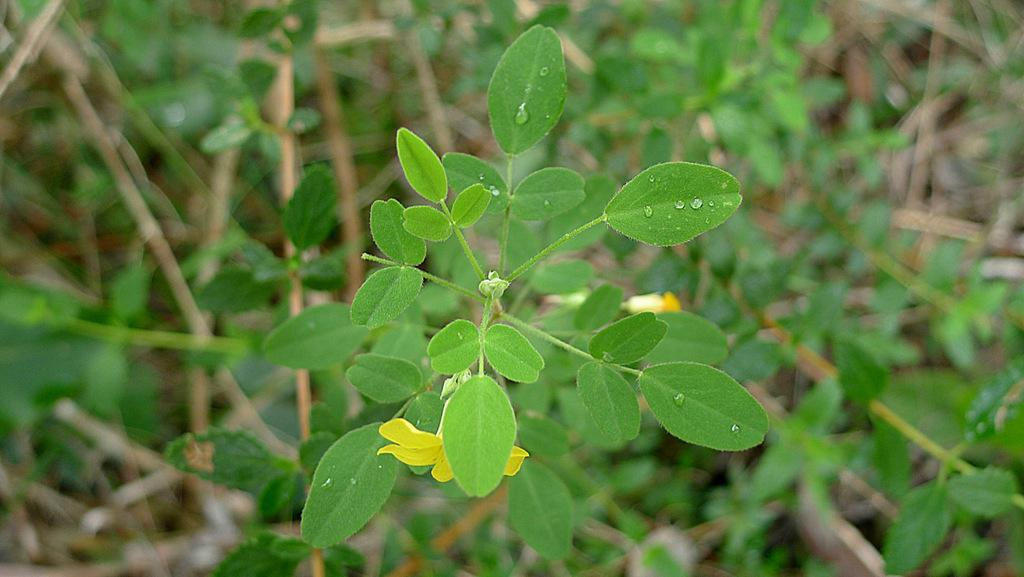What type of living organisms can be seen in the image? Plants can be seen in the image. Can you describe any specific features of the plants in the image? One of the plants has a yellow flower. What type of art can be seen on the plants in the image? There is no art present on the plants in the image; they are simply plants with a yellow flower. What experience might someone have while interacting with the plants in the image? The image does not depict any interaction with the plants, so it is not possible to determine what experience someone might have. 